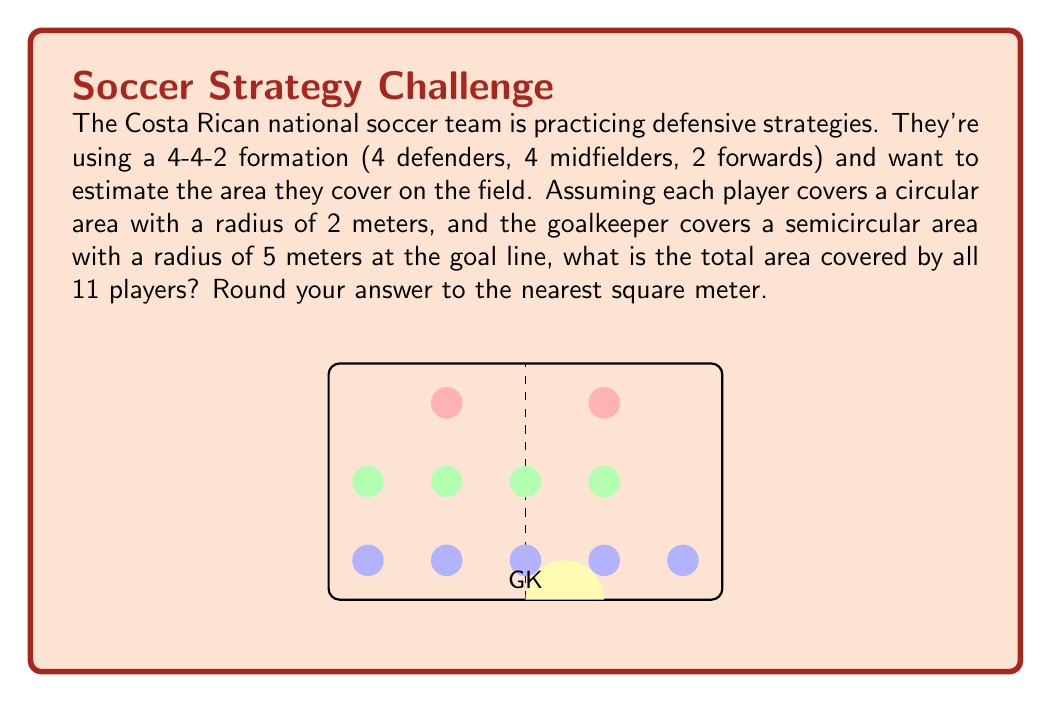What is the answer to this math problem? Let's approach this step-by-step:

1) First, let's calculate the area covered by a single outfield player:
   $$A_{player} = \pi r^2 = \pi (2m)^2 = 4\pi m^2$$

2) There are 10 outfield players, so the total area covered by them is:
   $$A_{outfield} = 10 \cdot 4\pi m^2 = 40\pi m^2$$

3) Now, let's calculate the area covered by the goalkeeper:
   The goalkeeper covers a semicircle with radius 5m.
   $$A_{goalkeeper} = \frac{1}{2} \pi r^2 = \frac{1}{2} \pi (5m)^2 = \frac{25\pi}{2} m^2$$

4) The total area covered is the sum of the outfield players' area and the goalkeeper's area:
   $$A_{total} = A_{outfield} + A_{goalkeeper} = 40\pi m^2 + \frac{25\pi}{2} m^2 = \frac{105\pi}{2} m^2$$

5) Let's calculate this:
   $$\frac{105\pi}{2} \approx 164.93 m^2$$

6) Rounding to the nearest square meter:
   $$165 m^2$$

Therefore, the total area covered by all 11 players is approximately 165 square meters.
Answer: 165 $m^2$ 